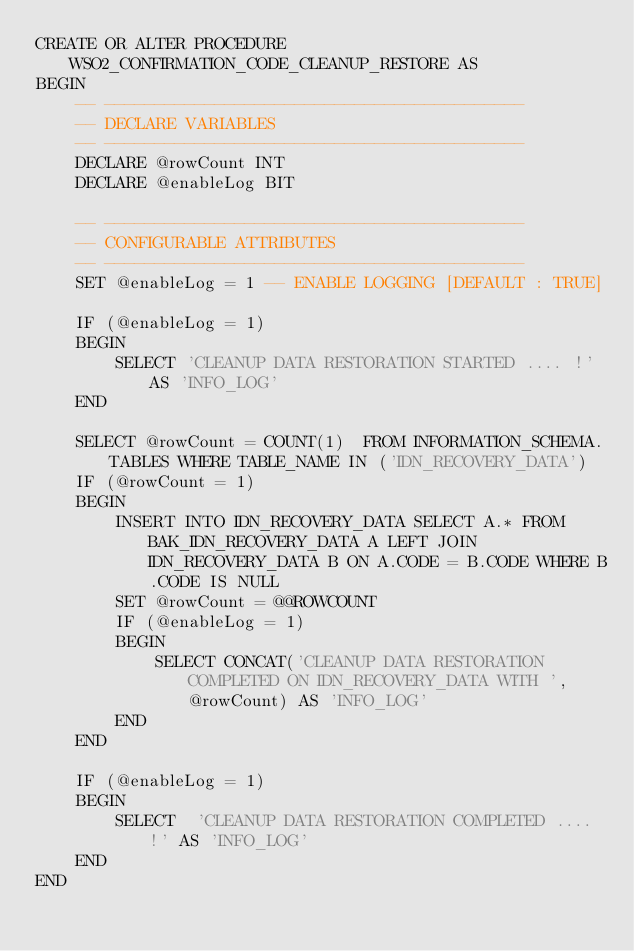<code> <loc_0><loc_0><loc_500><loc_500><_SQL_>CREATE OR ALTER PROCEDURE WSO2_CONFIRMATION_CODE_CLEANUP_RESTORE AS
BEGIN
    -- ------------------------------------------
    -- DECLARE VARIABLES
    -- ------------------------------------------
    DECLARE @rowCount INT
    DECLARE @enableLog BIT

    -- ------------------------------------------
    -- CONFIGURABLE ATTRIBUTES
    -- ------------------------------------------
    SET @enableLog = 1 -- ENABLE LOGGING [DEFAULT : TRUE]

    IF (@enableLog = 1)
    BEGIN
        SELECT 'CLEANUP DATA RESTORATION STARTED .... !' AS 'INFO_LOG'
    END

    SELECT @rowCount = COUNT(1)  FROM INFORMATION_SCHEMA.TABLES WHERE TABLE_NAME IN ('IDN_RECOVERY_DATA')
    IF (@rowCount = 1)
    BEGIN
        INSERT INTO IDN_RECOVERY_DATA SELECT A.* FROM BAK_IDN_RECOVERY_DATA A LEFT JOIN IDN_RECOVERY_DATA B ON A.CODE = B.CODE WHERE B.CODE IS NULL
        SET @rowCount = @@ROWCOUNT
        IF (@enableLog = 1)
        BEGIN
            SELECT CONCAT('CLEANUP DATA RESTORATION COMPLETED ON IDN_RECOVERY_DATA WITH ', @rowCount) AS 'INFO_LOG'
        END
    END

    IF (@enableLog = 1)
    BEGIN
        SELECT  'CLEANUP DATA RESTORATION COMPLETED .... !' AS 'INFO_LOG'
    END
END
</code> 